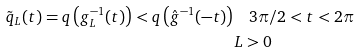Convert formula to latex. <formula><loc_0><loc_0><loc_500><loc_500>\tilde { q } _ { L } ( t ) = q \left ( g _ { L } ^ { - 1 } ( t ) \right ) < q \left ( \hat { g } ^ { - 1 } ( - t ) \right ) & \quad 3 \pi / 2 < t < 2 \pi \\ & L > 0</formula> 